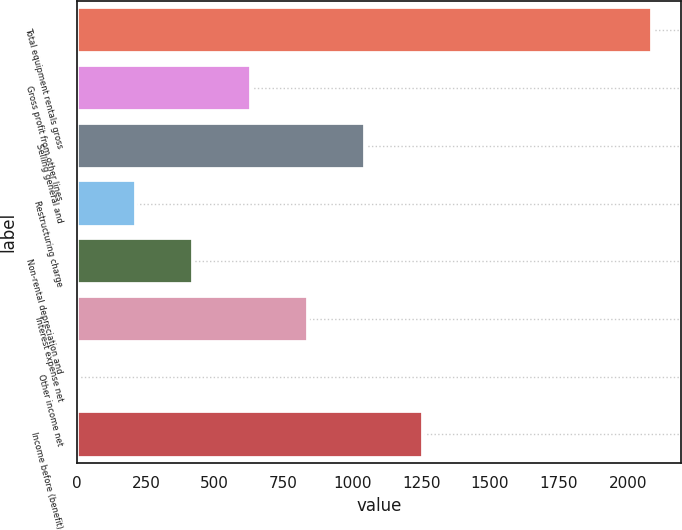<chart> <loc_0><loc_0><loc_500><loc_500><bar_chart><fcel>Total equipment rentals gross<fcel>Gross profit from other lines<fcel>Selling general and<fcel>Restructuring charge<fcel>Non-rental depreciation and<fcel>Interest expense net<fcel>Other income net<fcel>Income before (benefit)<nl><fcel>2089<fcel>630.2<fcel>1047<fcel>213.4<fcel>421.8<fcel>838.6<fcel>5<fcel>1255.4<nl></chart> 